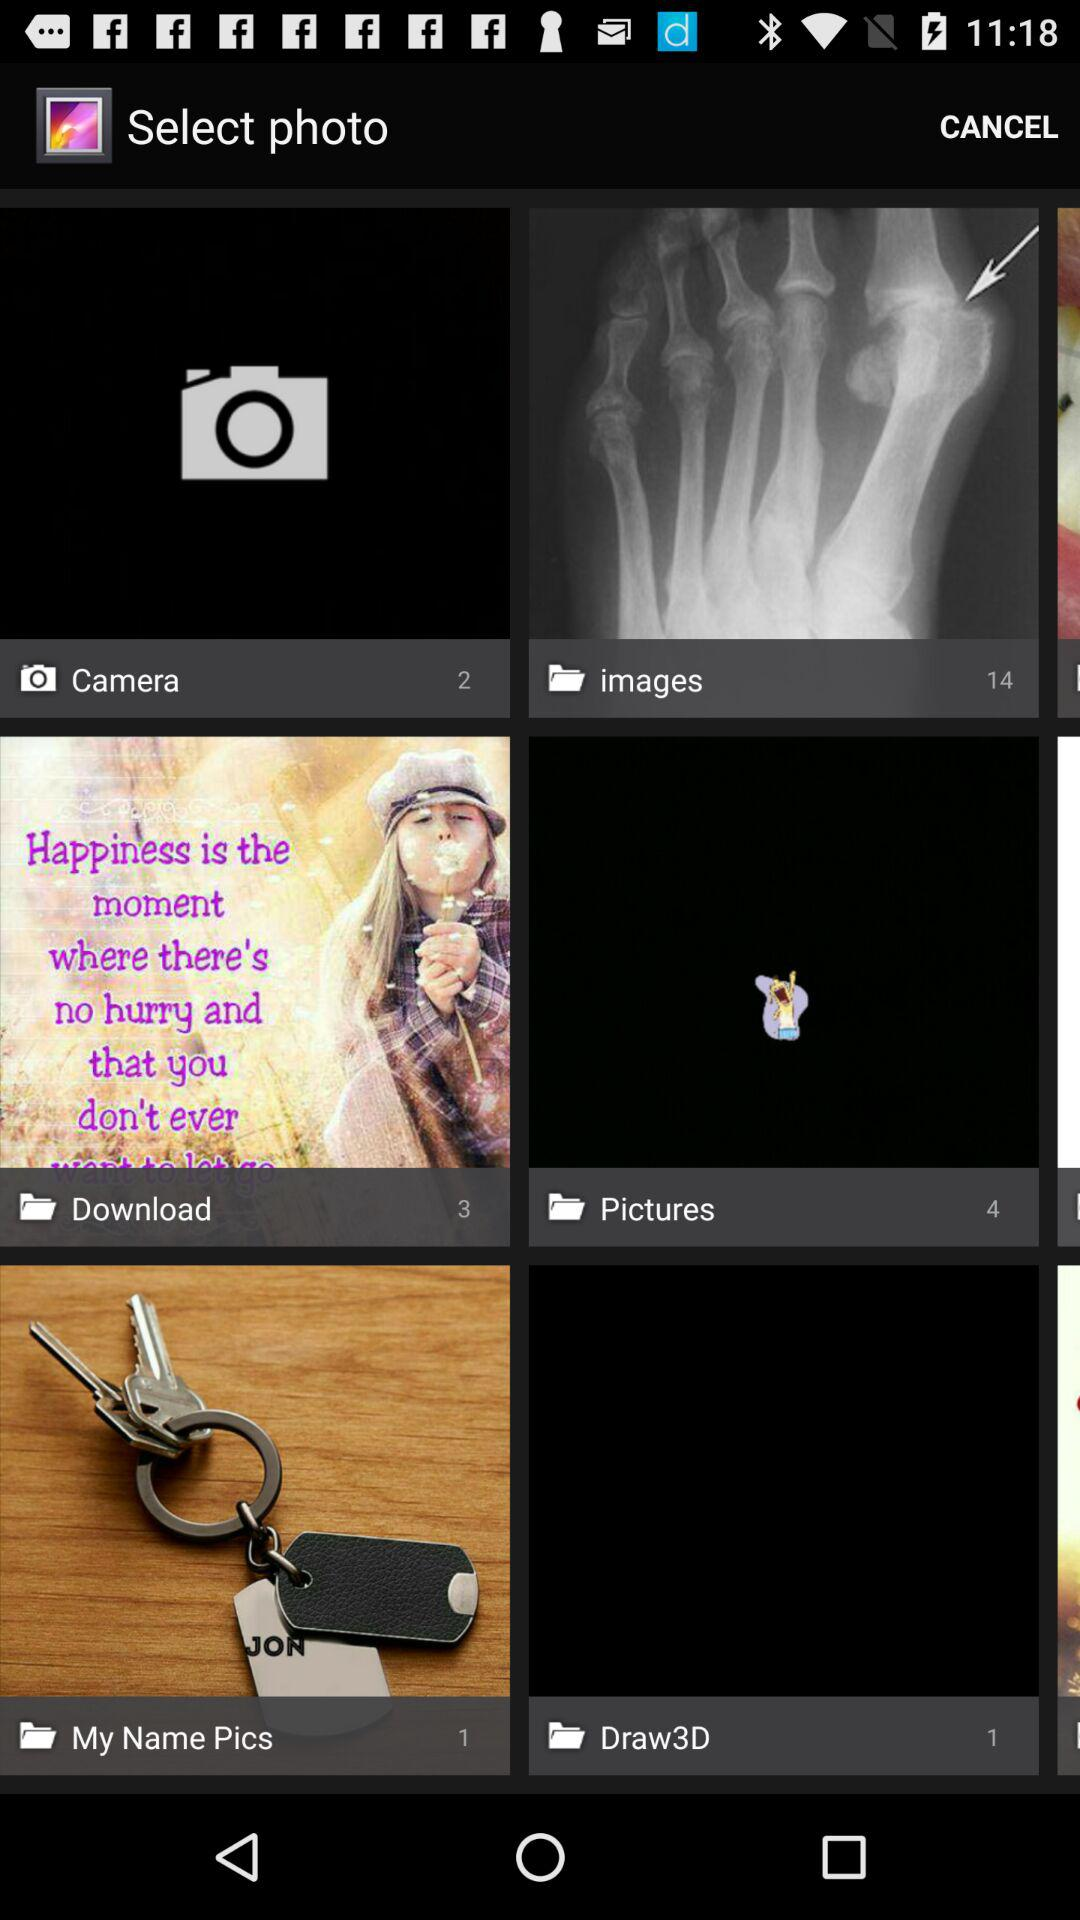How many pictures are there in the camera folder? There are 2 pictures. 